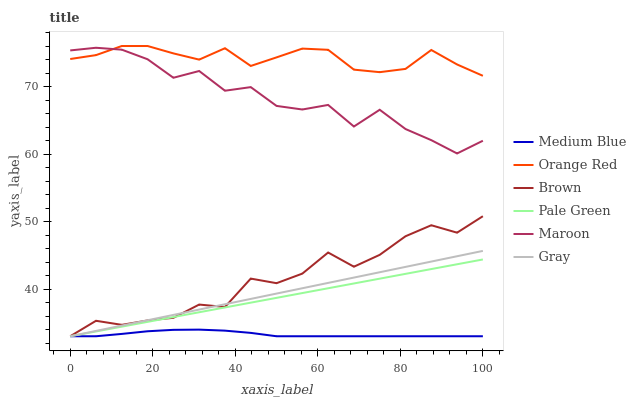Does Medium Blue have the minimum area under the curve?
Answer yes or no. Yes. Does Orange Red have the maximum area under the curve?
Answer yes or no. Yes. Does Gray have the minimum area under the curve?
Answer yes or no. No. Does Gray have the maximum area under the curve?
Answer yes or no. No. Is Gray the smoothest?
Answer yes or no. Yes. Is Maroon the roughest?
Answer yes or no. Yes. Is Medium Blue the smoothest?
Answer yes or no. No. Is Medium Blue the roughest?
Answer yes or no. No. Does Brown have the lowest value?
Answer yes or no. Yes. Does Maroon have the lowest value?
Answer yes or no. No. Does Orange Red have the highest value?
Answer yes or no. Yes. Does Gray have the highest value?
Answer yes or no. No. Is Gray less than Orange Red?
Answer yes or no. Yes. Is Orange Red greater than Medium Blue?
Answer yes or no. Yes. Does Medium Blue intersect Brown?
Answer yes or no. Yes. Is Medium Blue less than Brown?
Answer yes or no. No. Is Medium Blue greater than Brown?
Answer yes or no. No. Does Gray intersect Orange Red?
Answer yes or no. No. 